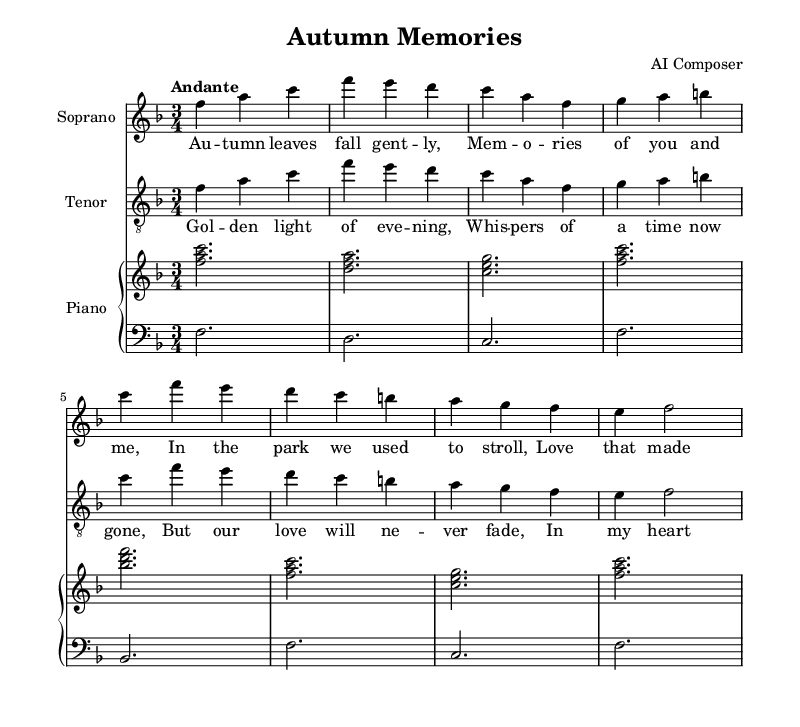What is the key signature of this music? The key signature is indicated at the beginning of the staff. In this sheet music, we see one flat, which corresponds to F major.
Answer: F major What is the time signature of this piece? The time signature is shown near the beginning of the staff, and it is indicated as 3/4, meaning there are three beats in each measure.
Answer: 3/4 What is the tempo marking for the music? The tempo is indicated at the top of the sheet music and is written as "Andante," which denotes a moderately slow tempo.
Answer: Andante How many measures are there in the soprano part? By counting the distinct sets of notes separated by vertical bars, we find there are a total of 8 measures in the soprano part.
Answer: 8 What is the relationship of the soprano and tenor voices in this duet? Both voices sing the same melody line with similar melodic phrases throughout the piece, indicating a duet form where they harmonize together.
Answer: Harmonizing What is the overall structure of this duet? The structure consists of alternating phrases where the soprano and tenor sing, comprising verses that elaborate on a theme of autumn memories.
Answer: Alternating verses What is the ensemble accompanying the duet? The accompanying part is provided for the piano, consisting of both right-hand and left-hand staves, which enhance the vocal melodies of the soprano and tenor.
Answer: Piano 